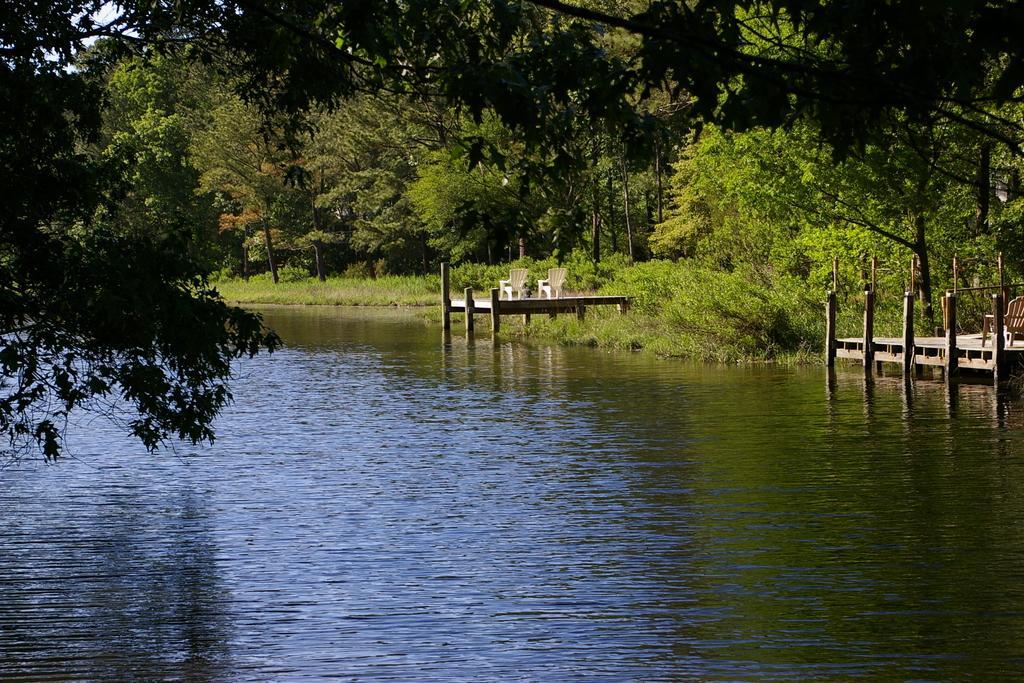Please provide a concise description of this image. In this image there is the water. To the left there are leaves of a tree. To the right there is a dock on the water. Beside it there is another dock. There are chairs on the dock. Behind it there are trees and grass on the ground. 